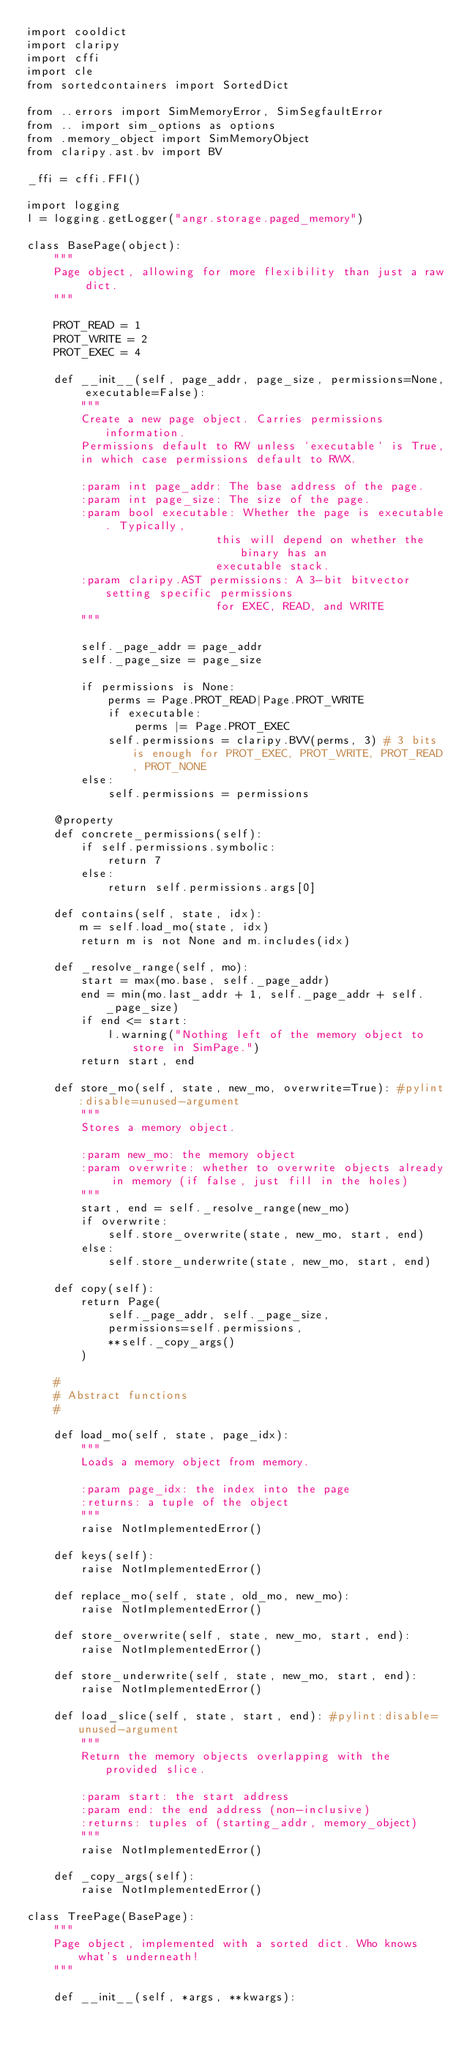<code> <loc_0><loc_0><loc_500><loc_500><_Python_>import cooldict
import claripy
import cffi
import cle
from sortedcontainers import SortedDict

from ..errors import SimMemoryError, SimSegfaultError
from .. import sim_options as options
from .memory_object import SimMemoryObject
from claripy.ast.bv import BV

_ffi = cffi.FFI()

import logging
l = logging.getLogger("angr.storage.paged_memory")

class BasePage(object):
    """
    Page object, allowing for more flexibility than just a raw dict.
    """

    PROT_READ = 1
    PROT_WRITE = 2
    PROT_EXEC = 4

    def __init__(self, page_addr, page_size, permissions=None, executable=False):
        """
        Create a new page object. Carries permissions information.
        Permissions default to RW unless `executable` is True,
        in which case permissions default to RWX.

        :param int page_addr: The base address of the page.
        :param int page_size: The size of the page.
        :param bool executable: Whether the page is executable. Typically,
                            this will depend on whether the binary has an
                            executable stack.
        :param claripy.AST permissions: A 3-bit bitvector setting specific permissions
                            for EXEC, READ, and WRITE
        """

        self._page_addr = page_addr
        self._page_size = page_size

        if permissions is None:
            perms = Page.PROT_READ|Page.PROT_WRITE
            if executable:
                perms |= Page.PROT_EXEC
            self.permissions = claripy.BVV(perms, 3) # 3 bits is enough for PROT_EXEC, PROT_WRITE, PROT_READ, PROT_NONE
        else:
            self.permissions = permissions

    @property
    def concrete_permissions(self):
        if self.permissions.symbolic:
            return 7
        else:
            return self.permissions.args[0]

    def contains(self, state, idx):
        m = self.load_mo(state, idx)
        return m is not None and m.includes(idx)

    def _resolve_range(self, mo):
        start = max(mo.base, self._page_addr)
        end = min(mo.last_addr + 1, self._page_addr + self._page_size)
        if end <= start:
            l.warning("Nothing left of the memory object to store in SimPage.")
        return start, end

    def store_mo(self, state, new_mo, overwrite=True): #pylint:disable=unused-argument
        """
        Stores a memory object.

        :param new_mo: the memory object
        :param overwrite: whether to overwrite objects already in memory (if false, just fill in the holes)
        """
        start, end = self._resolve_range(new_mo)
        if overwrite:
            self.store_overwrite(state, new_mo, start, end)
        else:
            self.store_underwrite(state, new_mo, start, end)

    def copy(self):
        return Page(
            self._page_addr, self._page_size,
            permissions=self.permissions,
            **self._copy_args()
        )

    #
    # Abstract functions
    #

    def load_mo(self, state, page_idx):
        """
        Loads a memory object from memory.

        :param page_idx: the index into the page
        :returns: a tuple of the object
        """
        raise NotImplementedError()

    def keys(self):
        raise NotImplementedError()

    def replace_mo(self, state, old_mo, new_mo):
        raise NotImplementedError()

    def store_overwrite(self, state, new_mo, start, end):
        raise NotImplementedError()

    def store_underwrite(self, state, new_mo, start, end):
        raise NotImplementedError()

    def load_slice(self, state, start, end): #pylint:disable=unused-argument
        """
        Return the memory objects overlapping with the provided slice.

        :param start: the start address
        :param end: the end address (non-inclusive)
        :returns: tuples of (starting_addr, memory_object)
        """
        raise NotImplementedError()

    def _copy_args(self):
        raise NotImplementedError()

class TreePage(BasePage):
    """
    Page object, implemented with a sorted dict. Who knows what's underneath!
    """

    def __init__(self, *args, **kwargs):</code> 